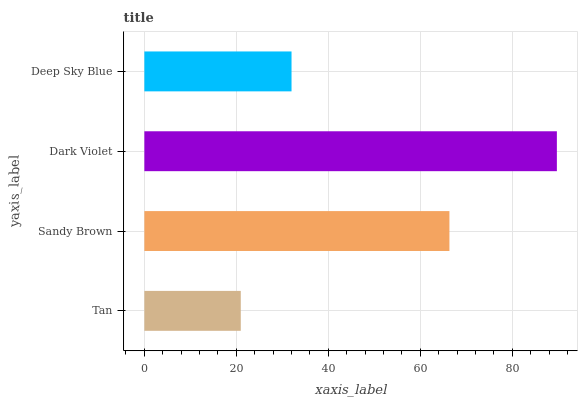Is Tan the minimum?
Answer yes or no. Yes. Is Dark Violet the maximum?
Answer yes or no. Yes. Is Sandy Brown the minimum?
Answer yes or no. No. Is Sandy Brown the maximum?
Answer yes or no. No. Is Sandy Brown greater than Tan?
Answer yes or no. Yes. Is Tan less than Sandy Brown?
Answer yes or no. Yes. Is Tan greater than Sandy Brown?
Answer yes or no. No. Is Sandy Brown less than Tan?
Answer yes or no. No. Is Sandy Brown the high median?
Answer yes or no. Yes. Is Deep Sky Blue the low median?
Answer yes or no. Yes. Is Tan the high median?
Answer yes or no. No. Is Dark Violet the low median?
Answer yes or no. No. 